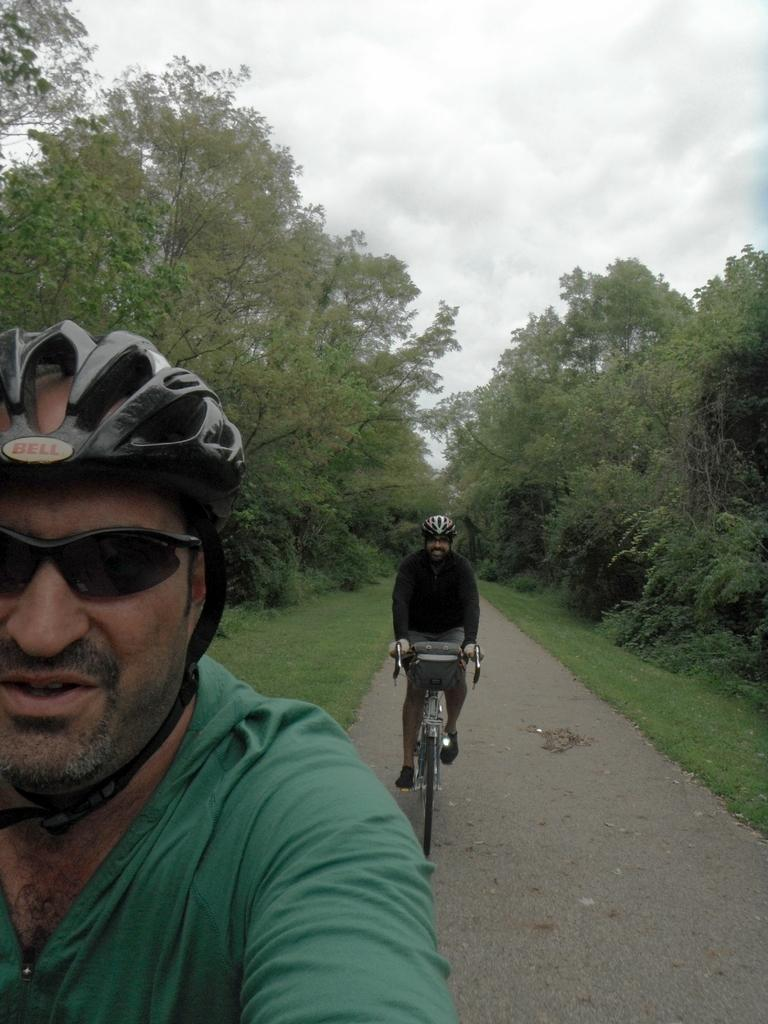What is the person in the image wearing on their upper body? The person in the image is wearing a green shirt. What protective gear is the person wearing in the image? The person is wearing goggles and a helmet. What is the other person in the image doing? The other person is riding a cycle in the image. What type of vegetation is present on both sides of the scene? There are trees on both sides of the scene. What type of ground surface is visible in the image? There is a green lawn in the image. What part of the natural environment is visible above the scene? The sky is visible above the scene. What is the condition of the boy's bicycle in the image? There is no boy or bicycle present in the image. 